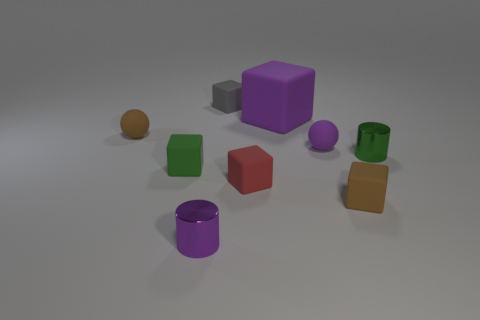Subtract all small green matte blocks. How many blocks are left? 4 Subtract all gray blocks. How many blocks are left? 4 Subtract all yellow blocks. Subtract all blue balls. How many blocks are left? 5 Add 1 green matte cubes. How many objects exist? 10 Subtract all cylinders. How many objects are left? 7 Subtract all gray things. Subtract all tiny red rubber things. How many objects are left? 7 Add 7 red rubber objects. How many red rubber objects are left? 8 Add 6 brown matte cubes. How many brown matte cubes exist? 7 Subtract 0 yellow spheres. How many objects are left? 9 